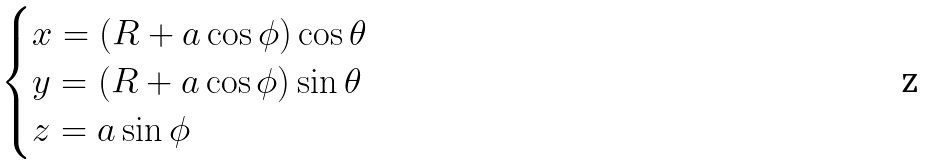Convert formula to latex. <formula><loc_0><loc_0><loc_500><loc_500>\begin{cases} x = ( R + a \cos \phi ) \cos \theta \\ y = ( R + a \cos \phi ) \sin \theta \\ z = a \sin \phi \end{cases}</formula> 